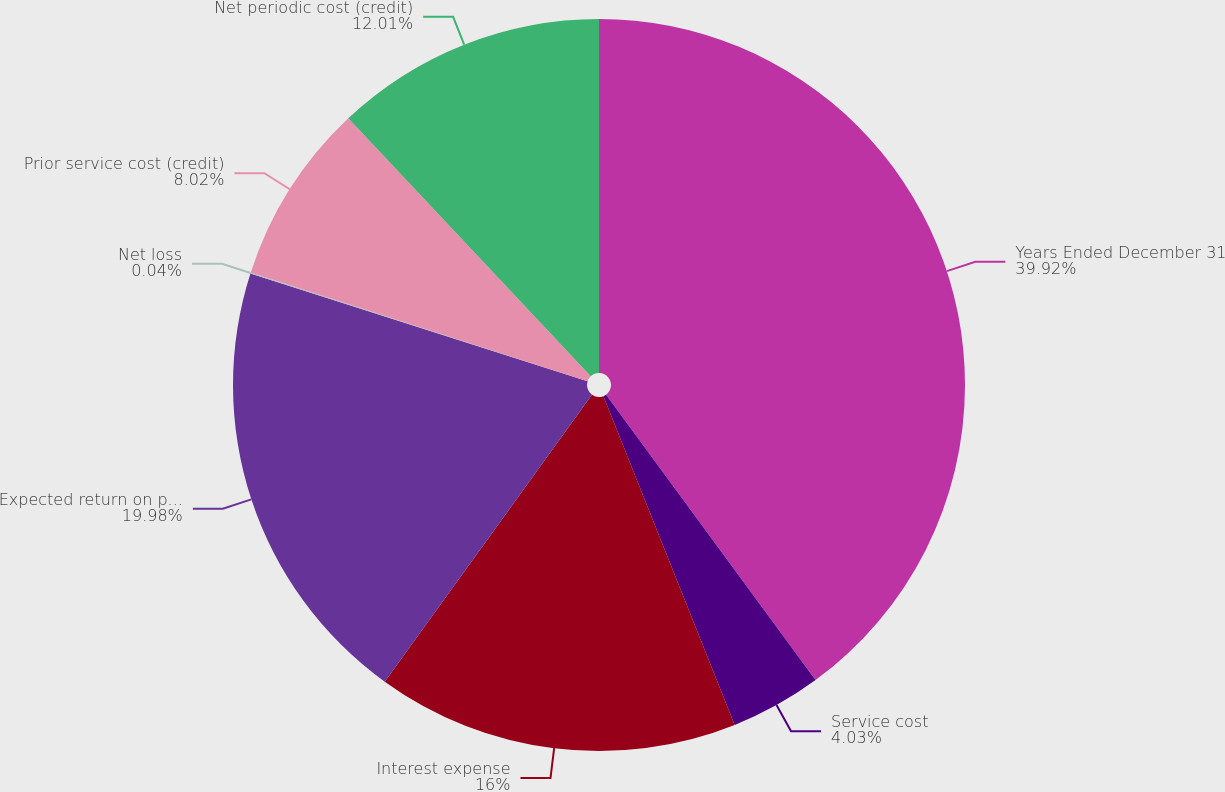Convert chart. <chart><loc_0><loc_0><loc_500><loc_500><pie_chart><fcel>Years Ended December 31<fcel>Service cost<fcel>Interest expense<fcel>Expected return on plan assets<fcel>Net loss<fcel>Prior service cost (credit)<fcel>Net periodic cost (credit)<nl><fcel>39.93%<fcel>4.03%<fcel>16.0%<fcel>19.98%<fcel>0.04%<fcel>8.02%<fcel>12.01%<nl></chart> 